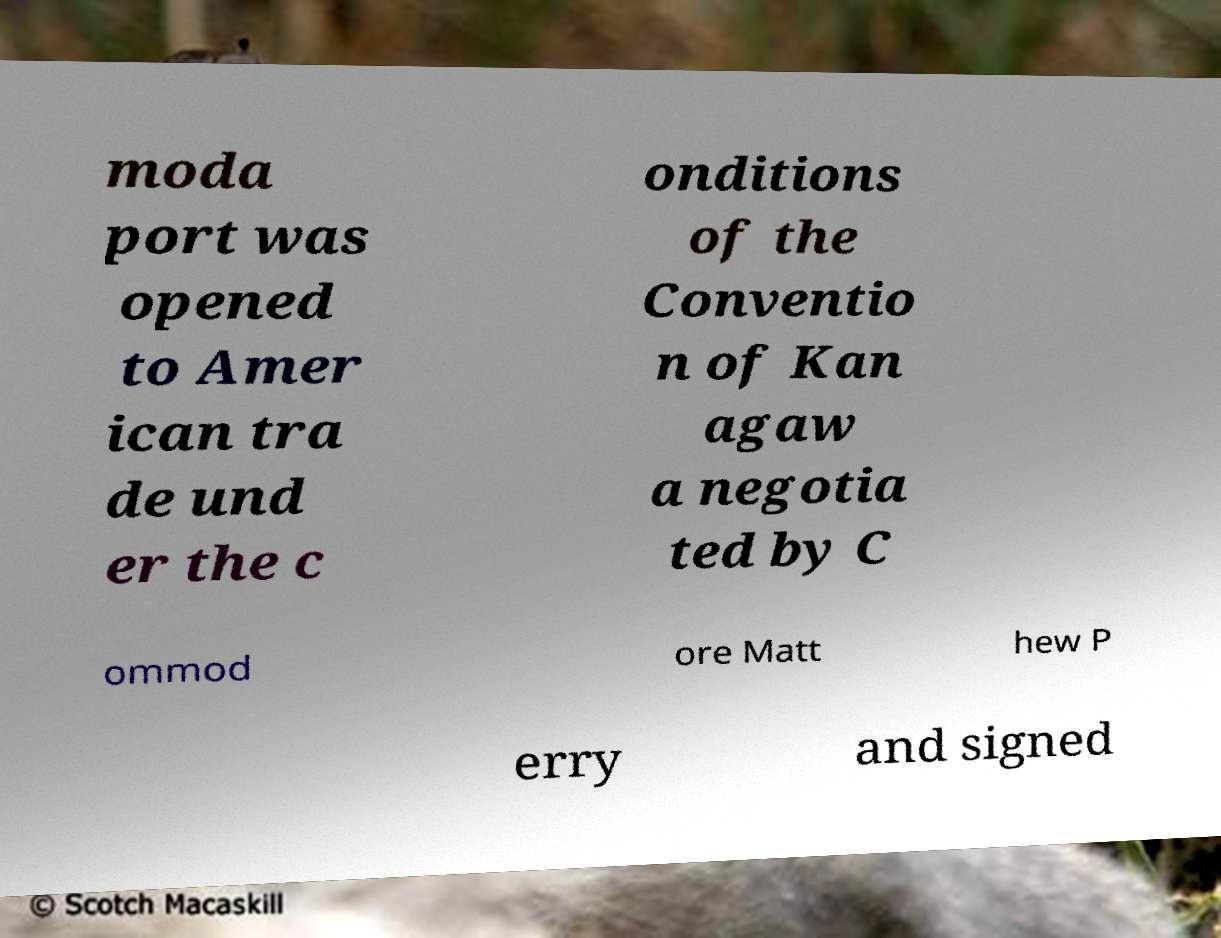Can you accurately transcribe the text from the provided image for me? moda port was opened to Amer ican tra de und er the c onditions of the Conventio n of Kan agaw a negotia ted by C ommod ore Matt hew P erry and signed 